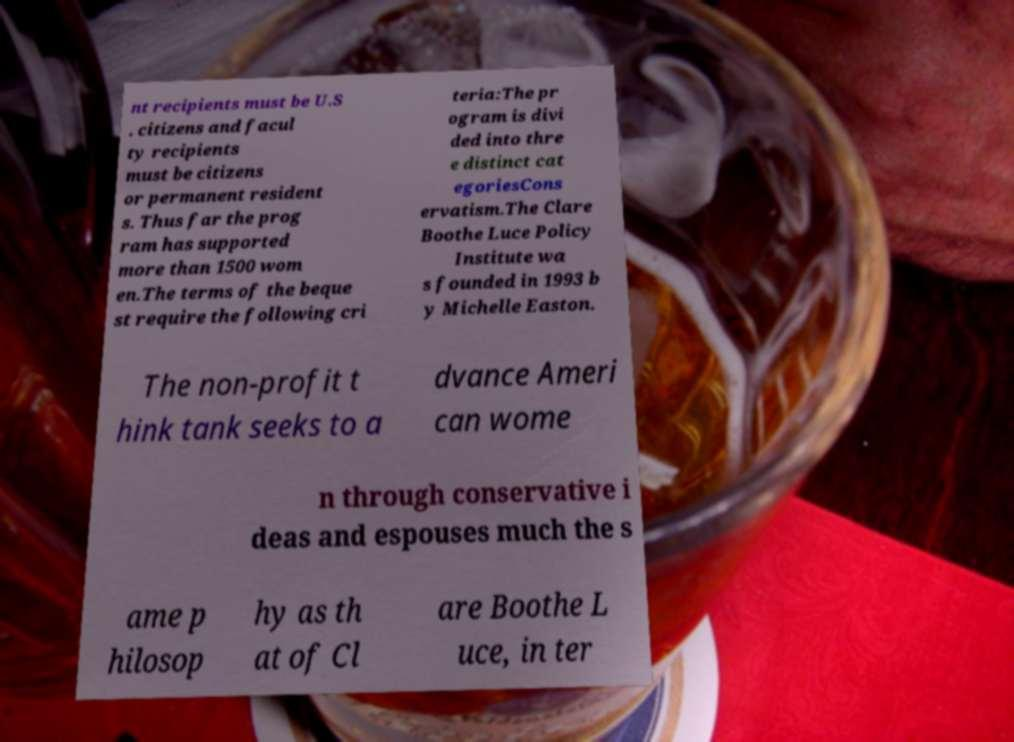Could you assist in decoding the text presented in this image and type it out clearly? nt recipients must be U.S . citizens and facul ty recipients must be citizens or permanent resident s. Thus far the prog ram has supported more than 1500 wom en.The terms of the beque st require the following cri teria:The pr ogram is divi ded into thre e distinct cat egoriesCons ervatism.The Clare Boothe Luce Policy Institute wa s founded in 1993 b y Michelle Easton. The non-profit t hink tank seeks to a dvance Ameri can wome n through conservative i deas and espouses much the s ame p hilosop hy as th at of Cl are Boothe L uce, in ter 